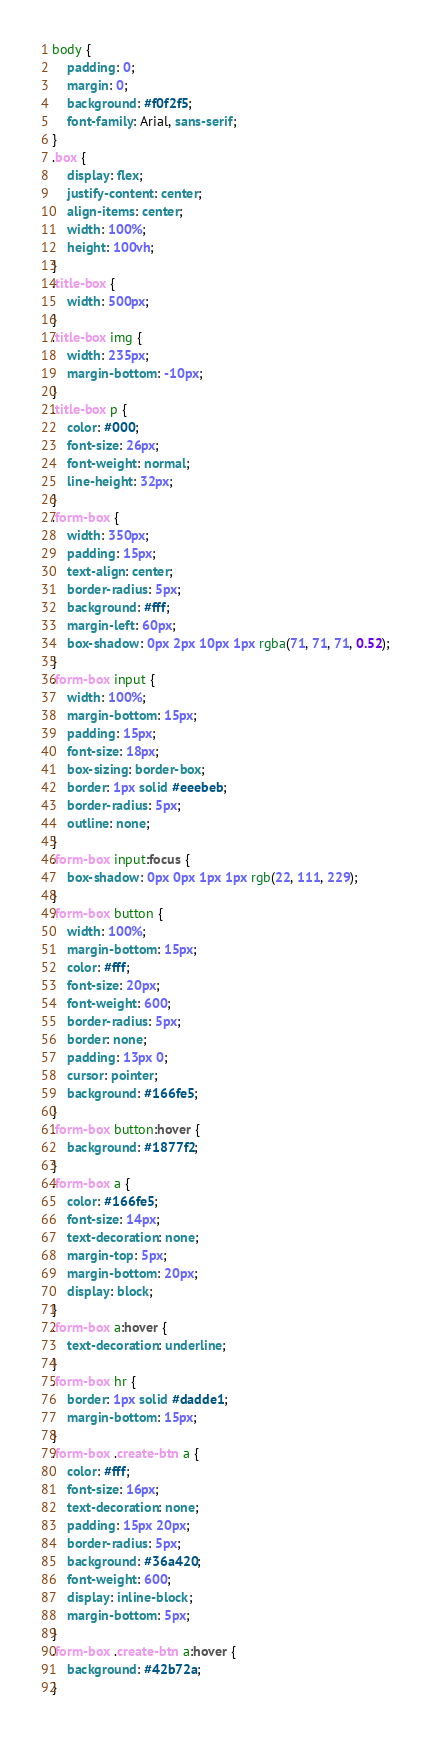<code> <loc_0><loc_0><loc_500><loc_500><_CSS_>body {
    padding: 0;
    margin: 0;
    background: #f0f2f5;
    font-family: Arial, sans-serif;
}
.box {
    display: flex;
    justify-content: center;
    align-items: center;
    width: 100%;
    height: 100vh;
}
.title-box {
    width: 500px;
}
.title-box img {
    width: 235px;
    margin-bottom: -10px;
}
.title-box p {
    color: #000;
    font-size: 26px;
    font-weight: normal;
    line-height: 32px;
}
.form-box {
    width: 350px;
    padding: 15px;
    text-align: center;
    border-radius: 5px;
    background: #fff;
    margin-left: 60px;
    box-shadow: 0px 2px 10px 1px rgba(71, 71, 71, 0.52);
}
.form-box input {
    width: 100%;
    margin-bottom: 15px;
    padding: 15px;
    font-size: 18px;
    box-sizing: border-box;
    border: 1px solid #eeebeb;
    border-radius: 5px;
    outline: none;
}
.form-box input:focus {
    box-shadow: 0px 0px 1px 1px rgb(22, 111, 229);
}
.form-box button {
    width: 100%;
    margin-bottom: 15px;
    color: #fff;
    font-size: 20px;
    font-weight: 600;
    border-radius: 5px;
    border: none;
    padding: 13px 0;
    cursor: pointer;
    background: #166fe5;
}
.form-box button:hover {
    background: #1877f2;
}
.form-box a {
    color: #166fe5;
    font-size: 14px;
    text-decoration: none;
    margin-top: 5px;
    margin-bottom: 20px;
    display: block;
}
.form-box a:hover {
    text-decoration: underline;
}
.form-box hr {
    border: 1px solid #dadde1;
    margin-bottom: 15px;
}
.form-box .create-btn a {
    color: #fff;
    font-size: 16px;
    text-decoration: none;
    padding: 15px 20px;
    border-radius: 5px;
    background: #36a420;
    font-weight: 600;
    display: inline-block;
    margin-bottom: 5px;
}
.form-box .create-btn a:hover {
    background: #42b72a;
}</code> 